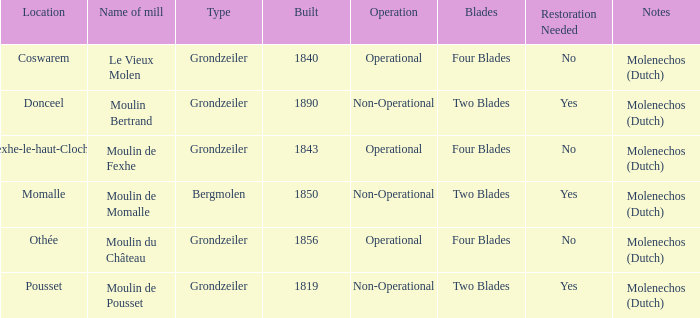What is the Location of the Moulin Bertrand Mill? Donceel. 